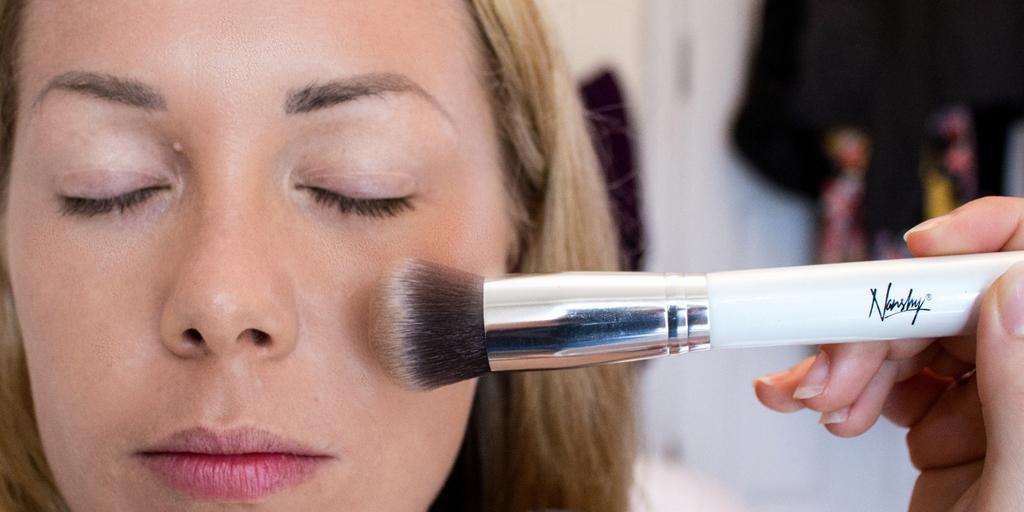How would you summarize this image in a sentence or two? On the left side, there is a woman having closed her eyes. On the right side, there is a hand of a person holding a brush and placing it near to this woman. And the background is blurred. 